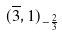Convert formula to latex. <formula><loc_0><loc_0><loc_500><loc_500>( \overline { 3 } , 1 ) _ { - \frac { 2 } { 3 } }</formula> 